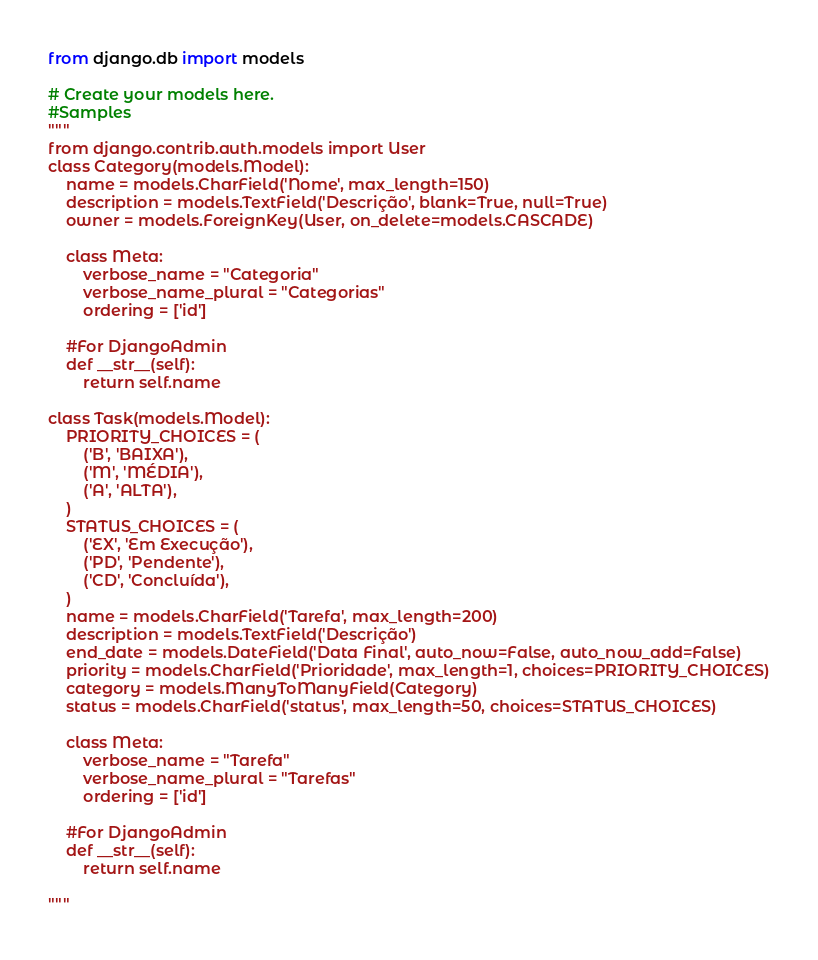Convert code to text. <code><loc_0><loc_0><loc_500><loc_500><_Python_>from django.db import models

# Create your models here.
#Samples
"""
from django.contrib.auth.models import User
class Category(models.Model):
    name = models.CharField('Nome', max_length=150)
    description = models.TextField('Descrição', blank=True, null=True)
    owner = models.ForeignKey(User, on_delete=models.CASCADE)

    class Meta:
        verbose_name = "Categoria"
        verbose_name_plural = "Categorias"
        ordering = ['id']
    
    #For DjangoAdmin
    def __str__(self):
        return self.name

class Task(models.Model):
    PRIORITY_CHOICES = (
        ('B', 'BAIXA'),
        ('M', 'MÉDIA'),
        ('A', 'ALTA'),
    )
    STATUS_CHOICES = (
        ('EX', 'Em Execução'),
        ('PD', 'Pendente'),
        ('CD', 'Concluída'),
    )
    name = models.CharField('Tarefa', max_length=200)
    description = models.TextField('Descrição')
    end_date = models.DateField('Data Final', auto_now=False, auto_now_add=False)
    priority = models.CharField('Prioridade', max_length=1, choices=PRIORITY_CHOICES)
    category = models.ManyToManyField(Category)
    status = models.CharField('status', max_length=50, choices=STATUS_CHOICES)

    class Meta:
        verbose_name = "Tarefa"
        verbose_name_plural = "Tarefas"
        ordering = ['id']
    
    #For DjangoAdmin
    def __str__(self):
        return self.name

"""

</code> 